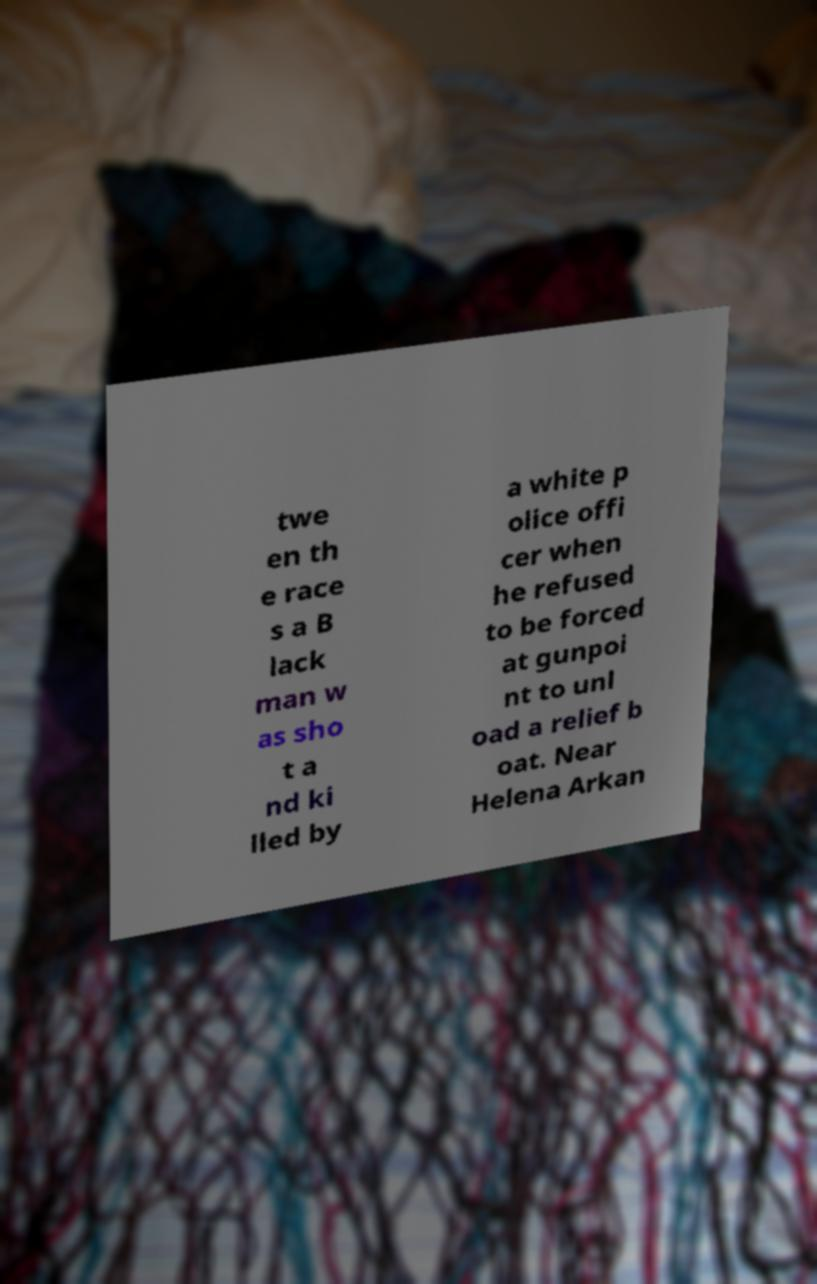There's text embedded in this image that I need extracted. Can you transcribe it verbatim? twe en th e race s a B lack man w as sho t a nd ki lled by a white p olice offi cer when he refused to be forced at gunpoi nt to unl oad a relief b oat. Near Helena Arkan 